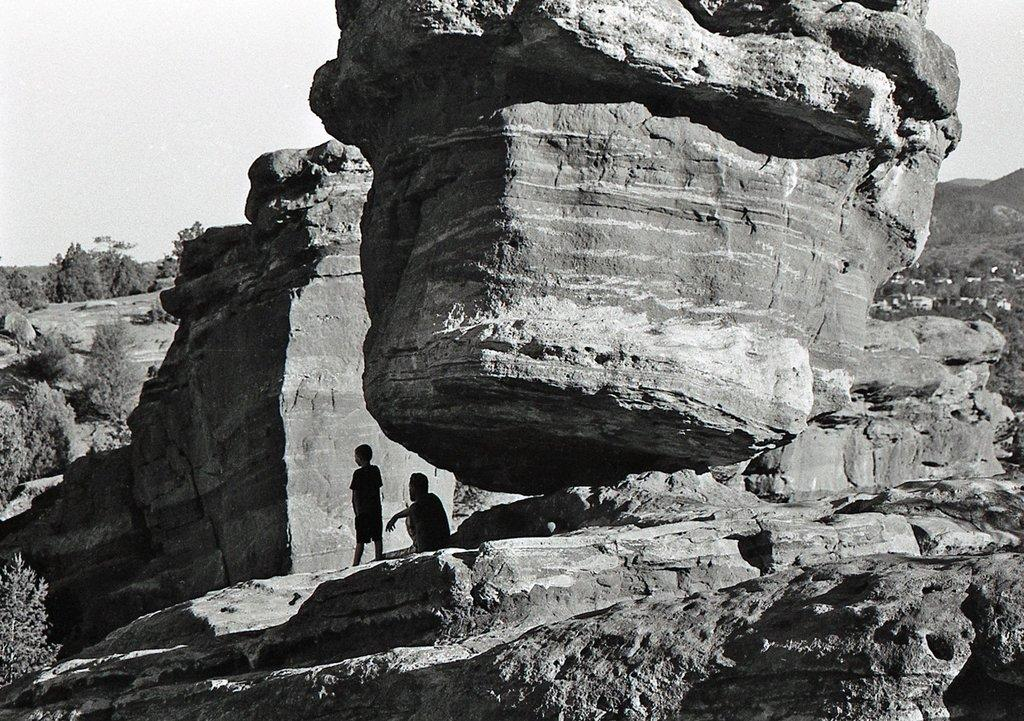What type of natural elements can be seen in the image? There are rocks, trees, and mountains in the image. How many people are present in the image? There are two people in the image. What is the color scheme of the image? The image is in black and white. What type of instrument is being played by the people in the image? There is no instrument present in the image; it only features rocks, trees, mountains, and two people. 